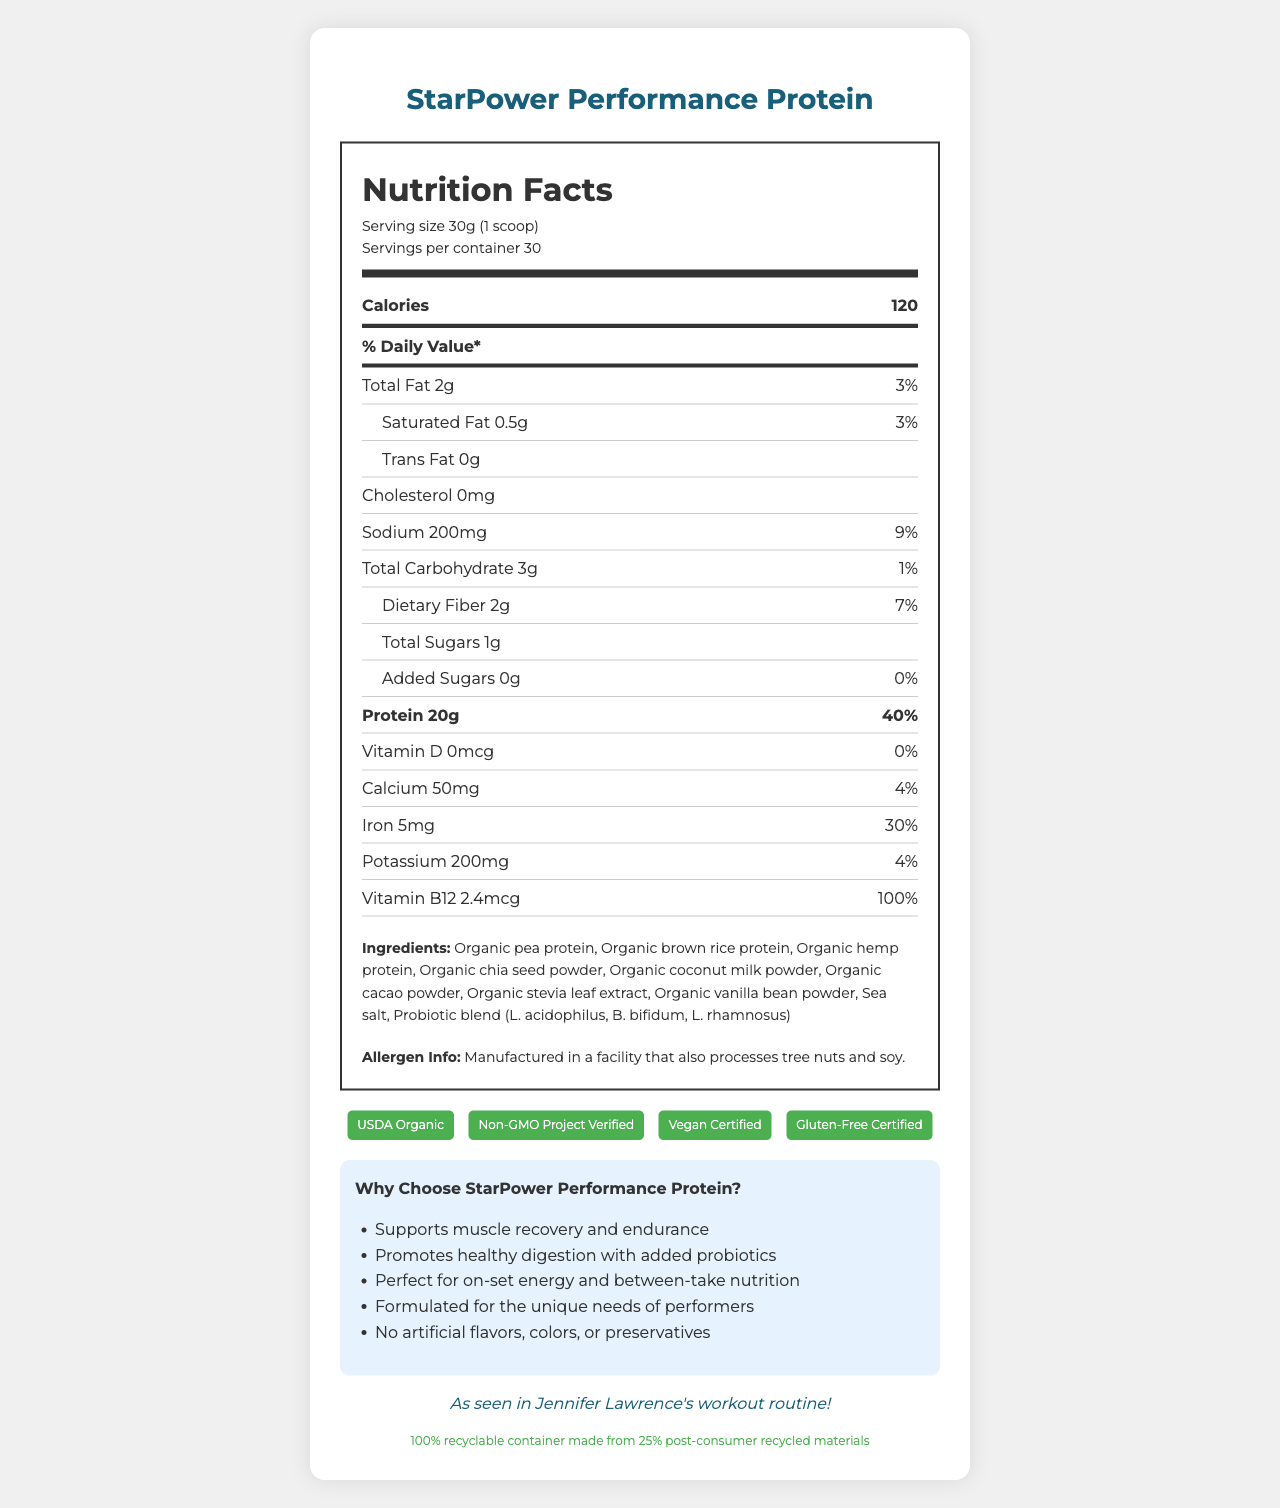what is the serving size? The serving size is explicitly mentioned as "30g (1 scoop)" in the Nutrition Facts Label.
Answer: 30g (1 scoop) how many servings per container are there? The label clearly states that there are 30 servings per container.
Answer: 30 what is the amount of total fat per serving? The label shows that the total fat per serving is 2g, which is 3% of the daily value.
Answer: 2g what is the daily value percentage for iron? According to the label, the daily value percentage for iron is 30%.
Answer: 30% how much protein does one serving provide? The label indicates that one serving contains 20g of protein, providing 40% of the daily value.
Answer: 20g what is the allergen information for this product? The allergen information is stated at the bottom part of the document: "Manufactured in a facility that also processes tree nuts and soy."
Answer: Manufactured in a facility that also processes tree nuts and soy. who endorses this product? The celebrity endorsement section mentions that it is "As seen in Jennifer Lawrence's workout routine!"
Answer: Jennifer Lawrence what percentage of the daily value for calcium is provided by one serving? The label indicates that one serving provides 4% of the daily value for calcium.
Answer: 4% which three ingredients are listed first in the ingredients list? A. Organic pea protein, organic brown rice protein, organic hemp protein B. Organic chia seed powder, organic coconut milk powder, organic cacao powder C. Sea salt, probiotic blend, organic stevia leaf extract Organic pea protein, organic brown rice protein, and organic hemp protein are the first three ingredients listed.
Answer: A what certifications does this product have? A. USDA Organic B. Non-GMO Project Verified C. Vegan Certified D. Gluten-Free Certified E. All of the above The product has all the certifications mentioned: USDA Organic, Non-GMO Project Verified, Vegan Certified, and Gluten-Free Certified.
Answer: E is this product environmentally friendly? The document states that the packaging is 100% recyclable and made from 25% post-consumer recycled materials, which indicates it is environmentally friendly.
Answer: Yes what are the main marketing claims of this product? The marketing claims section lists all these points about the product.
Answer: Supports muscle recovery and endurance, promotes healthy digestion with added probiotics, perfect for on-set energy and between-take nutrition, formulated for the unique needs of performers, no artificial flavors, colors, or preservatives summarize the document. The summary covers the main components of the document, including nutritional information, detailed ingredients, certifications, endorsements, and marketing claims.
Answer: The document is a detailed Nutrition Facts Label for StarPower Performance Protein, a plant-based, non-GMO protein powder aimed at health-conscious performers. It includes information about serving size, calories, macronutrients, vitamins, minerals, ingredients, allergen information, certifications, and marketing claims. It is endorsed by Jennifer Lawrence and uses eco-friendly packaging. can the recommended daily intake of this product be determined from the document? The document doesn't provide information on the recommended daily intake. It only gives the nutritional content per serving.
Answer: Cannot be determined 